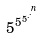Convert formula to latex. <formula><loc_0><loc_0><loc_500><loc_500>5 ^ { 5 ^ { 5 ^ { . ^ { . ^ { n } } } } }</formula> 